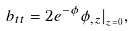Convert formula to latex. <formula><loc_0><loc_0><loc_500><loc_500>b _ { t t } = 2 e ^ { - \phi } \phi _ { , z } | _ { _ { z = 0 } } ,</formula> 